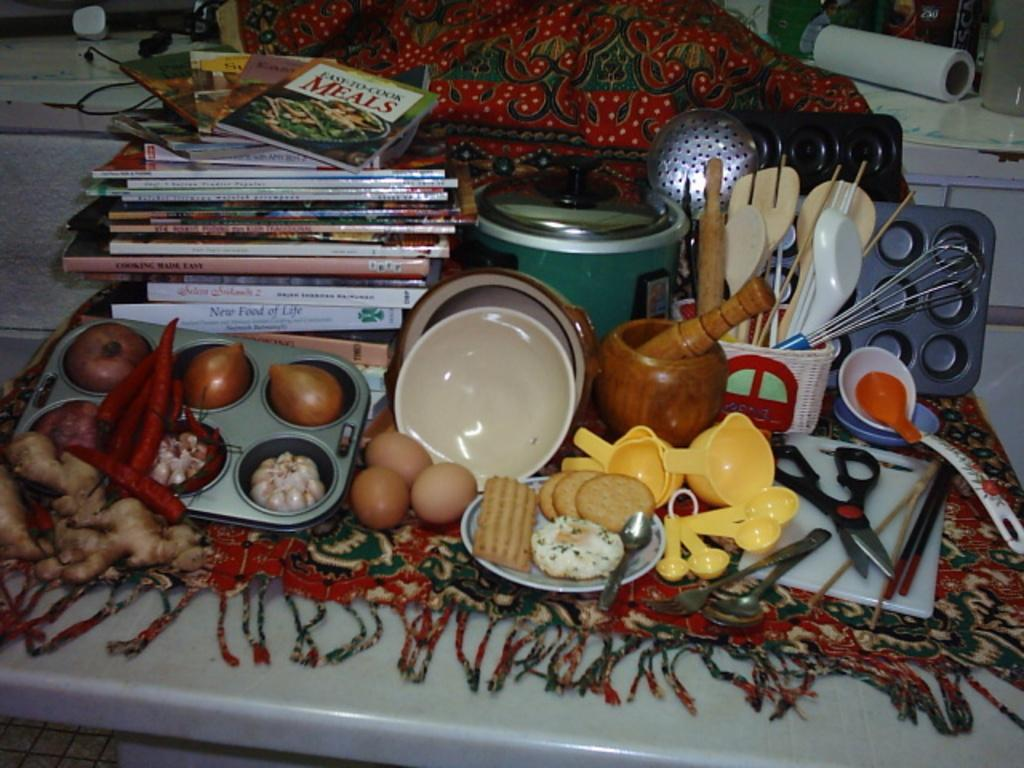<image>
Render a clear and concise summary of the photo. A cookbook called Easy To Cook Meals sits on a table with several ingredients 